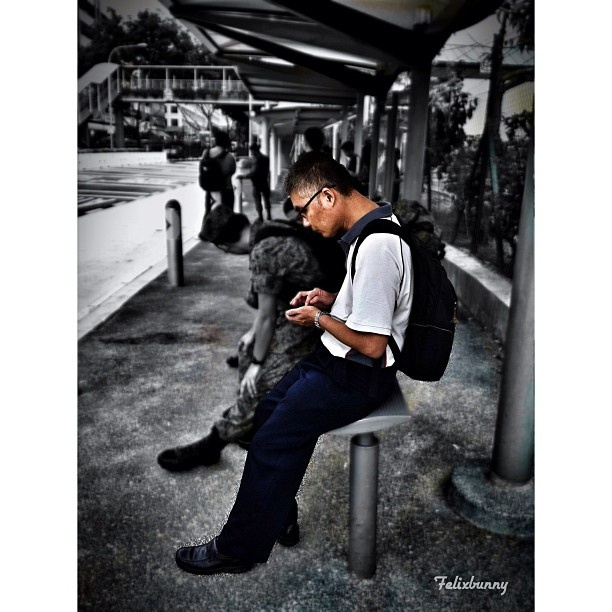Describe the objects in this image and their specific colors. I can see people in white, black, lightgray, darkgray, and brown tones, people in white, black, gray, and darkgray tones, backpack in white, black, gray, lightgray, and darkgray tones, bench in white, black, gray, and darkgray tones, and people in white, black, gray, darkgray, and lightgray tones in this image. 